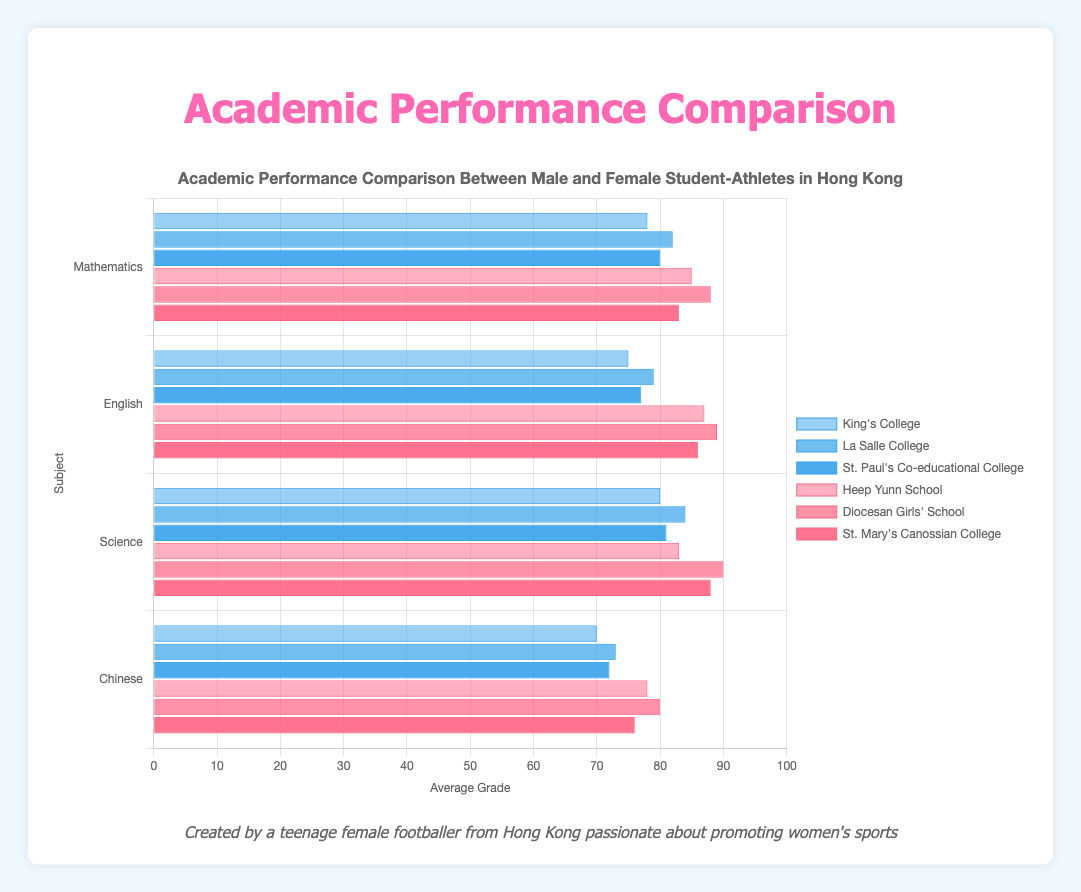What is the average grade for female student-athletes in Mathematics from Diocesan Girls' School? By looking at the bar for Diocesan Girls' School in the Mathematics section, we see that the average grade is 88.
Answer: 88 What is the difference between the highest and lowest average grades in Science for male student-athletes? To find the difference, identify the highest average grade (84 from La Salle College) and the lowest (80 from King's College) and subtract the lowest from the highest: 84 - 80 = 4.
Answer: 4 Who has the highest average grade in Chinese, male or female student-athletes? Compare the highest average grades for male (73 from La Salle College) and female (80 from Diocesan Girls' School) student-athletes in the Chinese section; 80 is higher.
Answer: Female student-athletes In English, which school has the highest average grade for female student-athletes? By looking at the bars for female student-athletes in the English section, the highest bar is from Diocesan Girls' School with an average grade of 89.
Answer: Diocesan Girls' School Which subject do female student-athletes perform best in? Compare the highest bars for female student-athletes across all subjects, finding that the highest average grade (90) is in Science from Diocesan Girls' School.
Answer: Science What is the combined average grade for male student-athletes in Mathematics from all schools? Sum the average grades of all male student-athletes in Mathematics: 78 (King's College) + 82 (La Salle College) + 80 (St. Paul's Co-educational College) = 240. The combined average grade is then 240 / 3 = 80.
Answer: 80 Between Mathematics and English, in which subject do male student-athletes from La Salle College perform better? Compare the average grades for male student-athletes from La Salle College: 82 in Mathematics and 79 in English. They perform better in Mathematics.
Answer: Mathematics How many more points does the highest performing female student-athlete in Science score compared to the highest performing male student-athlete? Identify the highest grades for female (90 from Diocesan Girls' School) and male (84 from La Salle College) student-athletes in Science. Then calculate the difference: 90 - 84 = 6.
Answer: 6 Which school shows a consistent higher average grade for female student-athletes across all subjects? Compare the average grades for female student-athletes across all subjects. Diocesan Girls' School has the highest or close to highest grades in each subject (88 in Mathematics, 89 in English, 90 in Science, and 80 in Chinese).
Answer: Diocesan Girls' School Calculate the average of the average grades in Chinese for both male and female student-athletes combined. Sum the average grades of all student-athletes in Chinese: (70 + 73 + 72) for males and (78 + 80 + 76) for females. Total is 70 + 73 + 72 + 78 + 80 + 76 = 449. There are 6 grades in total, so the average is 449 / 6 = 74.83.
Answer: 74.83 